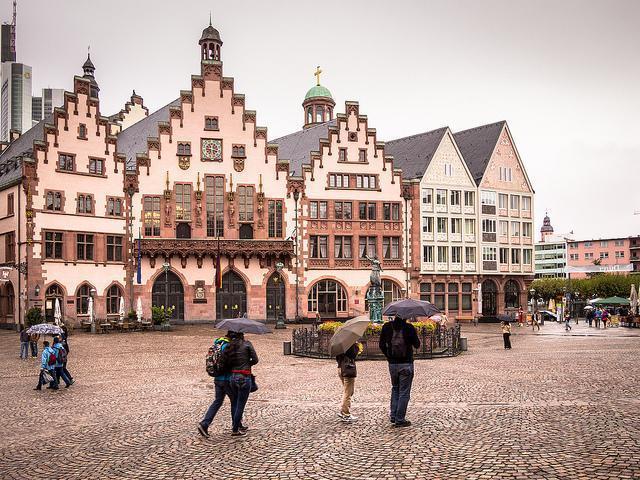How many leather couches are there in the living room?
Give a very brief answer. 0. 